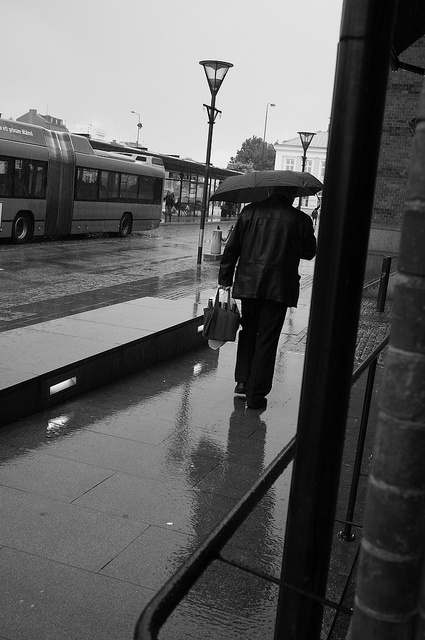Describe the objects in this image and their specific colors. I can see bus in lightgray, black, gray, and darkgray tones, people in lightgray, black, darkgray, and gray tones, umbrella in lightgray, black, gray, and darkgray tones, handbag in lightgray, black, darkgray, and gray tones, and people in lightgray, black, and gray tones in this image. 